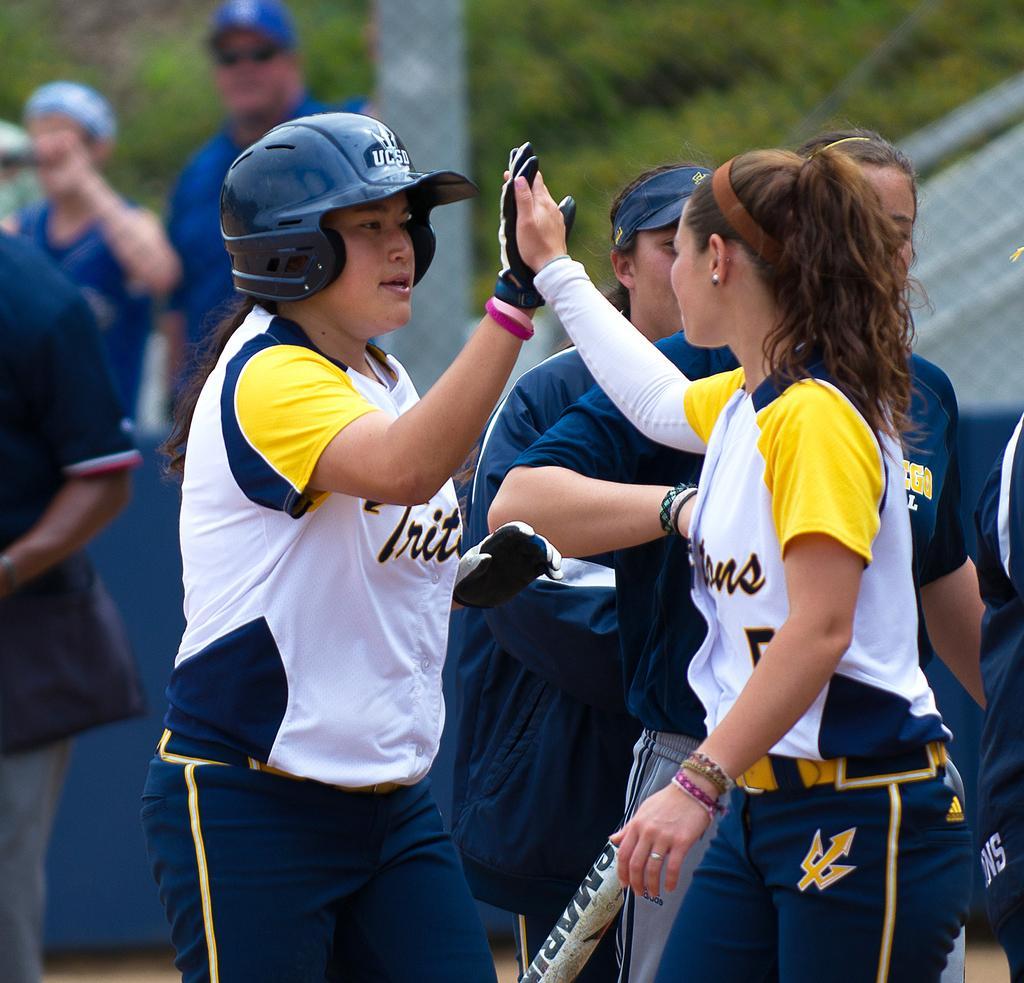Please provide a concise description of this image. In this image we can see some persons and other objects. In the background of the image there is a grass, persons and other objects. 